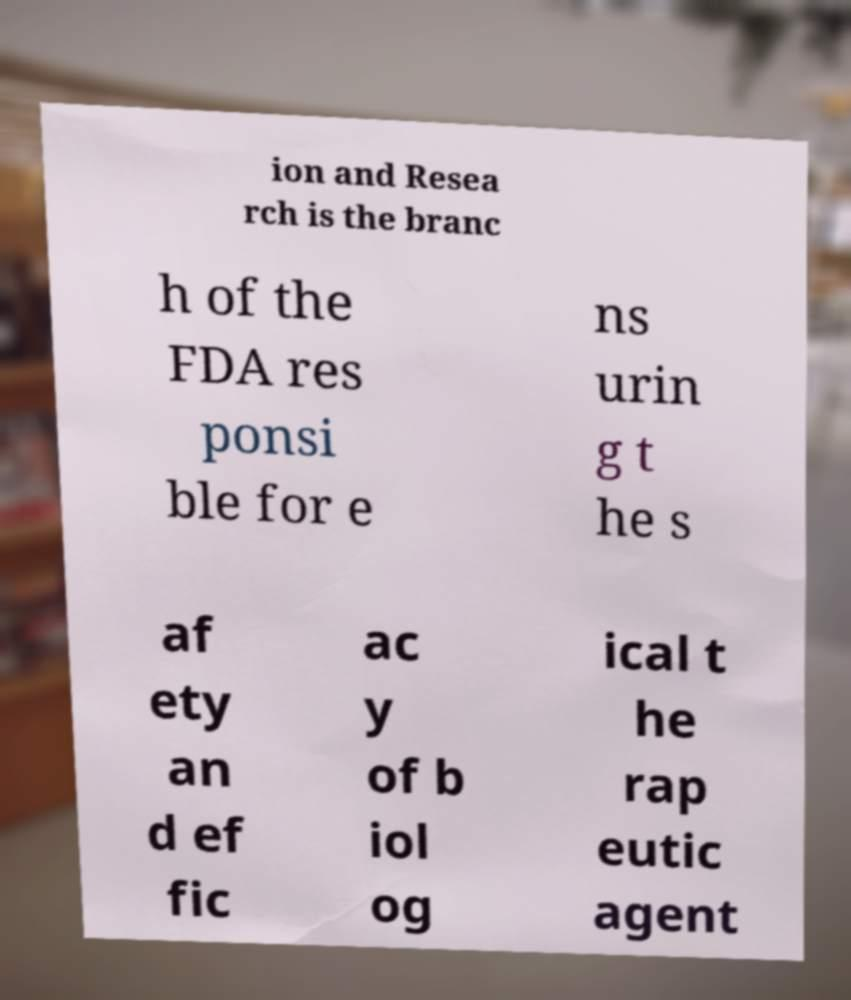What messages or text are displayed in this image? I need them in a readable, typed format. ion and Resea rch is the branc h of the FDA res ponsi ble for e ns urin g t he s af ety an d ef fic ac y of b iol og ical t he rap eutic agent 